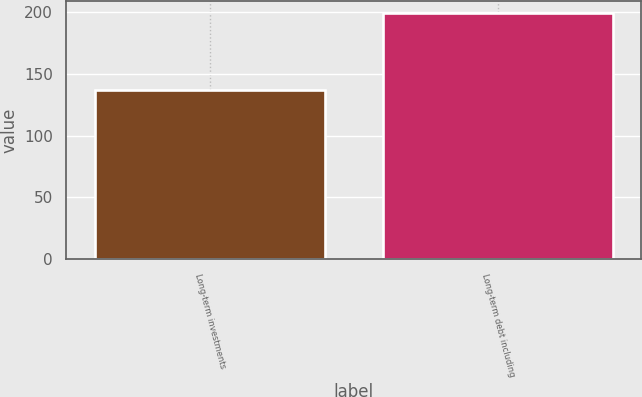<chart> <loc_0><loc_0><loc_500><loc_500><bar_chart><fcel>Long-term investments<fcel>Long-term debt including<nl><fcel>137<fcel>199<nl></chart> 